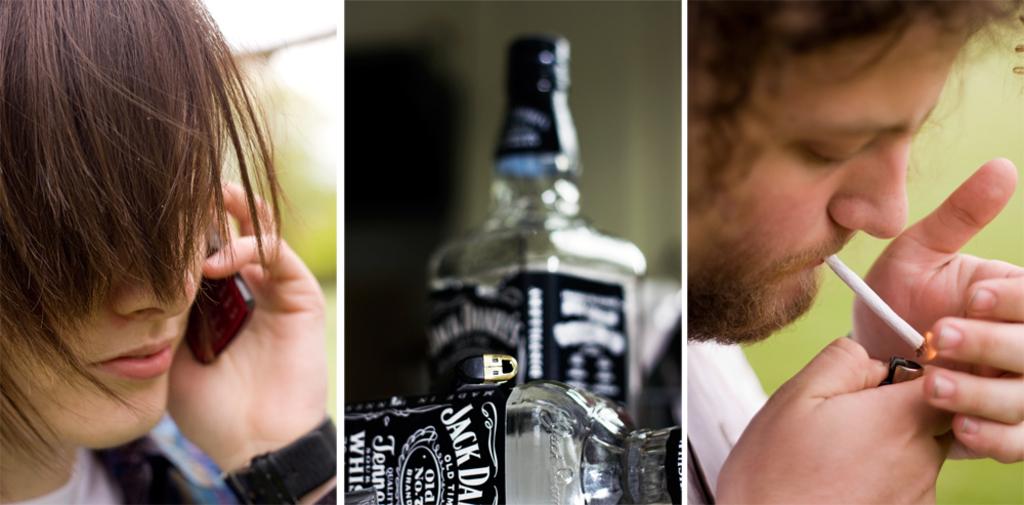What is the brand of the whisky bottle?
Provide a short and direct response. Jack daniels. Which state is the alcohol made in?
Your answer should be compact. Tennessee. 